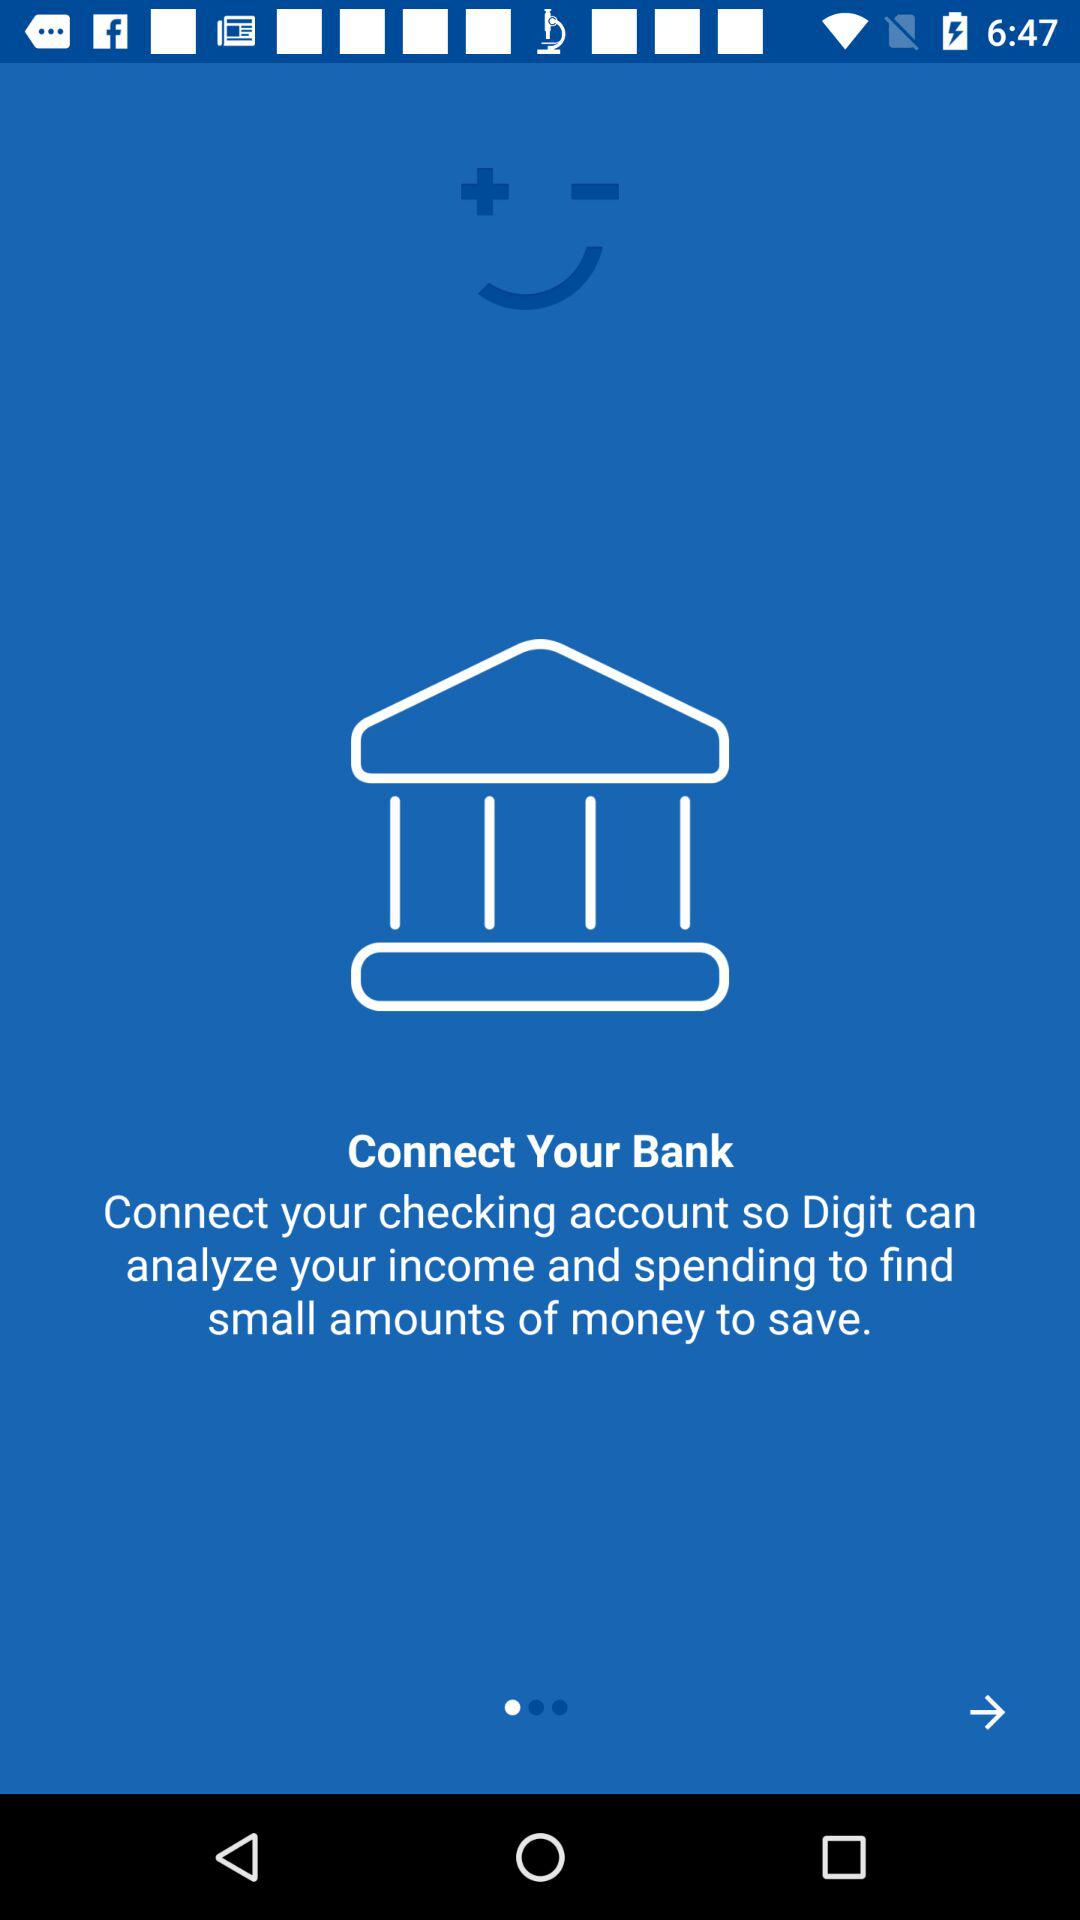What is the application name?
When the provided information is insufficient, respond with <no answer>. <no answer> 